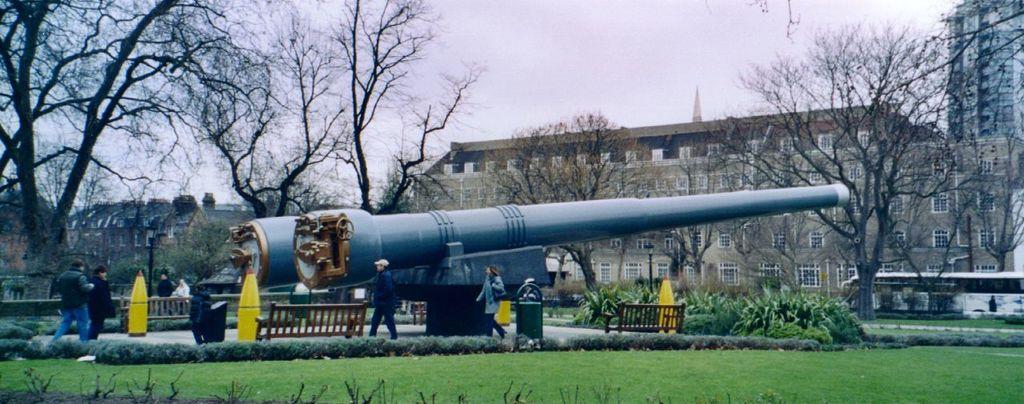How would you summarize this image in a sentence or two? In this image I can see some grass on the ground, few plants, few persons standing and a huge blue colored machinery. In the background I can see few trees, few benches, few yellow colored objects, few buildings and the sky. 